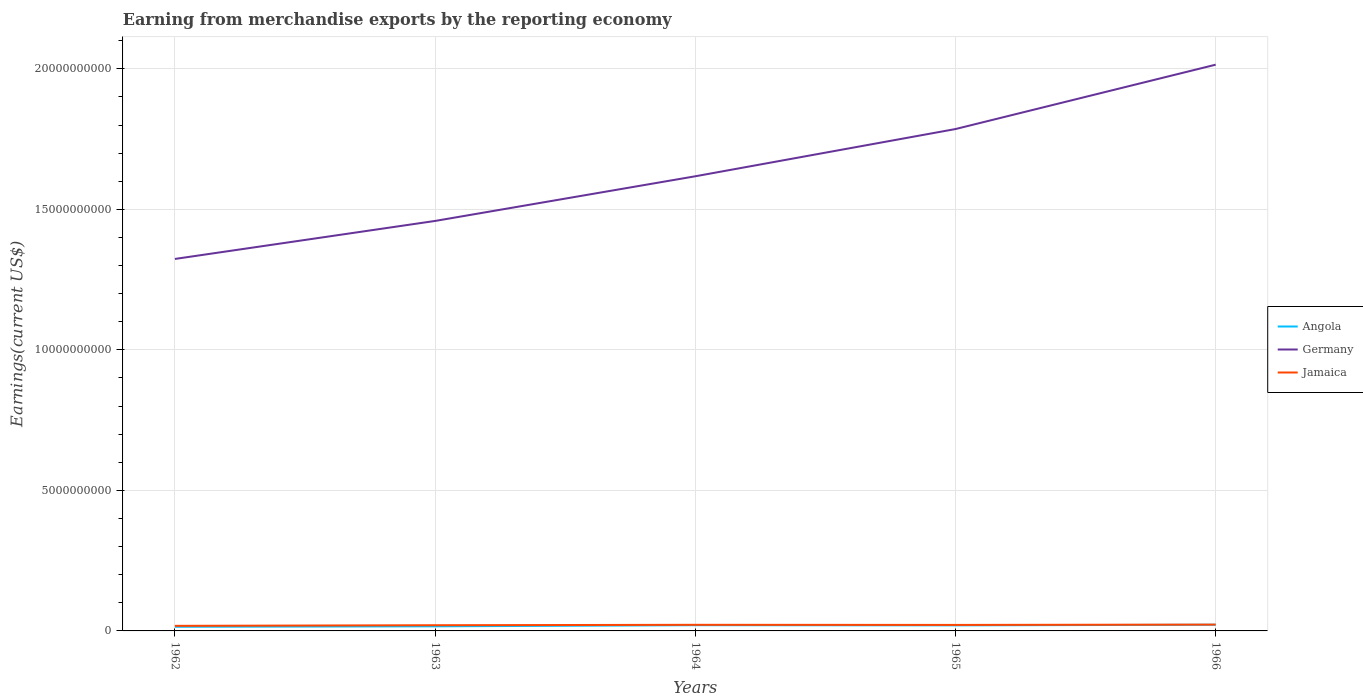How many different coloured lines are there?
Your answer should be compact. 3. Across all years, what is the maximum amount earned from merchandise exports in Jamaica?
Your response must be concise. 1.81e+08. In which year was the amount earned from merchandise exports in Angola maximum?
Offer a very short reply. 1962. What is the total amount earned from merchandise exports in Angola in the graph?
Your response must be concise. -1.62e+07. What is the difference between the highest and the second highest amount earned from merchandise exports in Germany?
Give a very brief answer. 6.91e+09. How many years are there in the graph?
Make the answer very short. 5. Does the graph contain any zero values?
Keep it short and to the point. No. Where does the legend appear in the graph?
Your response must be concise. Center right. How are the legend labels stacked?
Provide a short and direct response. Vertical. What is the title of the graph?
Make the answer very short. Earning from merchandise exports by the reporting economy. What is the label or title of the X-axis?
Your answer should be very brief. Years. What is the label or title of the Y-axis?
Your response must be concise. Earnings(current US$). What is the Earnings(current US$) in Angola in 1962?
Keep it short and to the point. 1.48e+08. What is the Earnings(current US$) in Germany in 1962?
Your response must be concise. 1.32e+1. What is the Earnings(current US$) in Jamaica in 1962?
Give a very brief answer. 1.81e+08. What is the Earnings(current US$) in Angola in 1963?
Make the answer very short. 1.64e+08. What is the Earnings(current US$) in Germany in 1963?
Provide a succinct answer. 1.46e+1. What is the Earnings(current US$) of Jamaica in 1963?
Give a very brief answer. 2.03e+08. What is the Earnings(current US$) of Angola in 1964?
Offer a very short reply. 2.04e+08. What is the Earnings(current US$) in Germany in 1964?
Keep it short and to the point. 1.62e+1. What is the Earnings(current US$) in Jamaica in 1964?
Offer a terse response. 2.18e+08. What is the Earnings(current US$) of Angola in 1965?
Your answer should be compact. 1.98e+08. What is the Earnings(current US$) of Germany in 1965?
Your response must be concise. 1.79e+1. What is the Earnings(current US$) of Jamaica in 1965?
Offer a terse response. 2.14e+08. What is the Earnings(current US$) of Angola in 1966?
Give a very brief answer. 2.20e+08. What is the Earnings(current US$) of Germany in 1966?
Keep it short and to the point. 2.01e+1. What is the Earnings(current US$) in Jamaica in 1966?
Ensure brevity in your answer.  2.25e+08. Across all years, what is the maximum Earnings(current US$) of Angola?
Your answer should be compact. 2.20e+08. Across all years, what is the maximum Earnings(current US$) of Germany?
Offer a terse response. 2.01e+1. Across all years, what is the maximum Earnings(current US$) of Jamaica?
Provide a succinct answer. 2.25e+08. Across all years, what is the minimum Earnings(current US$) in Angola?
Give a very brief answer. 1.48e+08. Across all years, what is the minimum Earnings(current US$) in Germany?
Ensure brevity in your answer.  1.32e+1. Across all years, what is the minimum Earnings(current US$) in Jamaica?
Offer a terse response. 1.81e+08. What is the total Earnings(current US$) in Angola in the graph?
Offer a terse response. 9.34e+08. What is the total Earnings(current US$) in Germany in the graph?
Provide a short and direct response. 8.20e+1. What is the total Earnings(current US$) in Jamaica in the graph?
Ensure brevity in your answer.  1.04e+09. What is the difference between the Earnings(current US$) in Angola in 1962 and that in 1963?
Make the answer very short. -1.58e+07. What is the difference between the Earnings(current US$) of Germany in 1962 and that in 1963?
Make the answer very short. -1.35e+09. What is the difference between the Earnings(current US$) in Jamaica in 1962 and that in 1963?
Provide a succinct answer. -2.21e+07. What is the difference between the Earnings(current US$) in Angola in 1962 and that in 1964?
Your answer should be very brief. -5.64e+07. What is the difference between the Earnings(current US$) in Germany in 1962 and that in 1964?
Provide a succinct answer. -2.94e+09. What is the difference between the Earnings(current US$) in Jamaica in 1962 and that in 1964?
Offer a very short reply. -3.68e+07. What is the difference between the Earnings(current US$) of Angola in 1962 and that in 1965?
Offer a terse response. -5.03e+07. What is the difference between the Earnings(current US$) in Germany in 1962 and that in 1965?
Keep it short and to the point. -4.62e+09. What is the difference between the Earnings(current US$) in Jamaica in 1962 and that in 1965?
Ensure brevity in your answer.  -3.29e+07. What is the difference between the Earnings(current US$) in Angola in 1962 and that in 1966?
Your response must be concise. -7.26e+07. What is the difference between the Earnings(current US$) in Germany in 1962 and that in 1966?
Ensure brevity in your answer.  -6.91e+09. What is the difference between the Earnings(current US$) in Jamaica in 1962 and that in 1966?
Offer a terse response. -4.45e+07. What is the difference between the Earnings(current US$) in Angola in 1963 and that in 1964?
Your answer should be very brief. -4.06e+07. What is the difference between the Earnings(current US$) in Germany in 1963 and that in 1964?
Offer a terse response. -1.59e+09. What is the difference between the Earnings(current US$) of Jamaica in 1963 and that in 1964?
Make the answer very short. -1.47e+07. What is the difference between the Earnings(current US$) of Angola in 1963 and that in 1965?
Ensure brevity in your answer.  -3.45e+07. What is the difference between the Earnings(current US$) of Germany in 1963 and that in 1965?
Provide a succinct answer. -3.27e+09. What is the difference between the Earnings(current US$) in Jamaica in 1963 and that in 1965?
Provide a short and direct response. -1.08e+07. What is the difference between the Earnings(current US$) in Angola in 1963 and that in 1966?
Offer a very short reply. -5.68e+07. What is the difference between the Earnings(current US$) of Germany in 1963 and that in 1966?
Provide a succinct answer. -5.56e+09. What is the difference between the Earnings(current US$) of Jamaica in 1963 and that in 1966?
Your response must be concise. -2.24e+07. What is the difference between the Earnings(current US$) in Angola in 1964 and that in 1965?
Your answer should be very brief. 6.10e+06. What is the difference between the Earnings(current US$) of Germany in 1964 and that in 1965?
Give a very brief answer. -1.68e+09. What is the difference between the Earnings(current US$) in Jamaica in 1964 and that in 1965?
Provide a succinct answer. 3.90e+06. What is the difference between the Earnings(current US$) of Angola in 1964 and that in 1966?
Provide a short and direct response. -1.62e+07. What is the difference between the Earnings(current US$) in Germany in 1964 and that in 1966?
Offer a very short reply. -3.97e+09. What is the difference between the Earnings(current US$) in Jamaica in 1964 and that in 1966?
Offer a very short reply. -7.70e+06. What is the difference between the Earnings(current US$) of Angola in 1965 and that in 1966?
Your response must be concise. -2.23e+07. What is the difference between the Earnings(current US$) in Germany in 1965 and that in 1966?
Give a very brief answer. -2.29e+09. What is the difference between the Earnings(current US$) in Jamaica in 1965 and that in 1966?
Your response must be concise. -1.16e+07. What is the difference between the Earnings(current US$) in Angola in 1962 and the Earnings(current US$) in Germany in 1963?
Your response must be concise. -1.44e+1. What is the difference between the Earnings(current US$) of Angola in 1962 and the Earnings(current US$) of Jamaica in 1963?
Provide a short and direct response. -5.51e+07. What is the difference between the Earnings(current US$) in Germany in 1962 and the Earnings(current US$) in Jamaica in 1963?
Provide a succinct answer. 1.30e+1. What is the difference between the Earnings(current US$) of Angola in 1962 and the Earnings(current US$) of Germany in 1964?
Offer a very short reply. -1.60e+1. What is the difference between the Earnings(current US$) of Angola in 1962 and the Earnings(current US$) of Jamaica in 1964?
Offer a very short reply. -6.98e+07. What is the difference between the Earnings(current US$) in Germany in 1962 and the Earnings(current US$) in Jamaica in 1964?
Offer a terse response. 1.30e+1. What is the difference between the Earnings(current US$) in Angola in 1962 and the Earnings(current US$) in Germany in 1965?
Your answer should be very brief. -1.77e+1. What is the difference between the Earnings(current US$) of Angola in 1962 and the Earnings(current US$) of Jamaica in 1965?
Your answer should be compact. -6.59e+07. What is the difference between the Earnings(current US$) of Germany in 1962 and the Earnings(current US$) of Jamaica in 1965?
Your answer should be compact. 1.30e+1. What is the difference between the Earnings(current US$) of Angola in 1962 and the Earnings(current US$) of Germany in 1966?
Offer a very short reply. -2.00e+1. What is the difference between the Earnings(current US$) in Angola in 1962 and the Earnings(current US$) in Jamaica in 1966?
Your response must be concise. -7.75e+07. What is the difference between the Earnings(current US$) in Germany in 1962 and the Earnings(current US$) in Jamaica in 1966?
Provide a short and direct response. 1.30e+1. What is the difference between the Earnings(current US$) of Angola in 1963 and the Earnings(current US$) of Germany in 1964?
Your response must be concise. -1.60e+1. What is the difference between the Earnings(current US$) of Angola in 1963 and the Earnings(current US$) of Jamaica in 1964?
Provide a short and direct response. -5.40e+07. What is the difference between the Earnings(current US$) of Germany in 1963 and the Earnings(current US$) of Jamaica in 1964?
Give a very brief answer. 1.44e+1. What is the difference between the Earnings(current US$) of Angola in 1963 and the Earnings(current US$) of Germany in 1965?
Your response must be concise. -1.77e+1. What is the difference between the Earnings(current US$) in Angola in 1963 and the Earnings(current US$) in Jamaica in 1965?
Make the answer very short. -5.01e+07. What is the difference between the Earnings(current US$) of Germany in 1963 and the Earnings(current US$) of Jamaica in 1965?
Provide a succinct answer. 1.44e+1. What is the difference between the Earnings(current US$) in Angola in 1963 and the Earnings(current US$) in Germany in 1966?
Keep it short and to the point. -2.00e+1. What is the difference between the Earnings(current US$) of Angola in 1963 and the Earnings(current US$) of Jamaica in 1966?
Make the answer very short. -6.17e+07. What is the difference between the Earnings(current US$) of Germany in 1963 and the Earnings(current US$) of Jamaica in 1966?
Keep it short and to the point. 1.44e+1. What is the difference between the Earnings(current US$) in Angola in 1964 and the Earnings(current US$) in Germany in 1965?
Your answer should be very brief. -1.77e+1. What is the difference between the Earnings(current US$) of Angola in 1964 and the Earnings(current US$) of Jamaica in 1965?
Your answer should be very brief. -9.50e+06. What is the difference between the Earnings(current US$) in Germany in 1964 and the Earnings(current US$) in Jamaica in 1965?
Keep it short and to the point. 1.60e+1. What is the difference between the Earnings(current US$) of Angola in 1964 and the Earnings(current US$) of Germany in 1966?
Make the answer very short. -1.99e+1. What is the difference between the Earnings(current US$) of Angola in 1964 and the Earnings(current US$) of Jamaica in 1966?
Your answer should be very brief. -2.11e+07. What is the difference between the Earnings(current US$) of Germany in 1964 and the Earnings(current US$) of Jamaica in 1966?
Ensure brevity in your answer.  1.60e+1. What is the difference between the Earnings(current US$) in Angola in 1965 and the Earnings(current US$) in Germany in 1966?
Ensure brevity in your answer.  -1.99e+1. What is the difference between the Earnings(current US$) in Angola in 1965 and the Earnings(current US$) in Jamaica in 1966?
Your answer should be very brief. -2.72e+07. What is the difference between the Earnings(current US$) in Germany in 1965 and the Earnings(current US$) in Jamaica in 1966?
Keep it short and to the point. 1.76e+1. What is the average Earnings(current US$) of Angola per year?
Ensure brevity in your answer.  1.87e+08. What is the average Earnings(current US$) of Germany per year?
Offer a terse response. 1.64e+1. What is the average Earnings(current US$) in Jamaica per year?
Provide a succinct answer. 2.08e+08. In the year 1962, what is the difference between the Earnings(current US$) in Angola and Earnings(current US$) in Germany?
Make the answer very short. -1.31e+1. In the year 1962, what is the difference between the Earnings(current US$) of Angola and Earnings(current US$) of Jamaica?
Make the answer very short. -3.30e+07. In the year 1962, what is the difference between the Earnings(current US$) in Germany and Earnings(current US$) in Jamaica?
Make the answer very short. 1.31e+1. In the year 1963, what is the difference between the Earnings(current US$) in Angola and Earnings(current US$) in Germany?
Your response must be concise. -1.44e+1. In the year 1963, what is the difference between the Earnings(current US$) of Angola and Earnings(current US$) of Jamaica?
Your answer should be compact. -3.93e+07. In the year 1963, what is the difference between the Earnings(current US$) of Germany and Earnings(current US$) of Jamaica?
Provide a short and direct response. 1.44e+1. In the year 1964, what is the difference between the Earnings(current US$) of Angola and Earnings(current US$) of Germany?
Keep it short and to the point. -1.60e+1. In the year 1964, what is the difference between the Earnings(current US$) of Angola and Earnings(current US$) of Jamaica?
Provide a short and direct response. -1.34e+07. In the year 1964, what is the difference between the Earnings(current US$) of Germany and Earnings(current US$) of Jamaica?
Ensure brevity in your answer.  1.60e+1. In the year 1965, what is the difference between the Earnings(current US$) of Angola and Earnings(current US$) of Germany?
Give a very brief answer. -1.77e+1. In the year 1965, what is the difference between the Earnings(current US$) in Angola and Earnings(current US$) in Jamaica?
Your answer should be compact. -1.56e+07. In the year 1965, what is the difference between the Earnings(current US$) of Germany and Earnings(current US$) of Jamaica?
Offer a terse response. 1.76e+1. In the year 1966, what is the difference between the Earnings(current US$) in Angola and Earnings(current US$) in Germany?
Make the answer very short. -1.99e+1. In the year 1966, what is the difference between the Earnings(current US$) of Angola and Earnings(current US$) of Jamaica?
Give a very brief answer. -4.90e+06. In the year 1966, what is the difference between the Earnings(current US$) in Germany and Earnings(current US$) in Jamaica?
Make the answer very short. 1.99e+1. What is the ratio of the Earnings(current US$) in Angola in 1962 to that in 1963?
Keep it short and to the point. 0.9. What is the ratio of the Earnings(current US$) in Germany in 1962 to that in 1963?
Ensure brevity in your answer.  0.91. What is the ratio of the Earnings(current US$) of Jamaica in 1962 to that in 1963?
Give a very brief answer. 0.89. What is the ratio of the Earnings(current US$) in Angola in 1962 to that in 1964?
Your response must be concise. 0.72. What is the ratio of the Earnings(current US$) in Germany in 1962 to that in 1964?
Your answer should be very brief. 0.82. What is the ratio of the Earnings(current US$) of Jamaica in 1962 to that in 1964?
Keep it short and to the point. 0.83. What is the ratio of the Earnings(current US$) of Angola in 1962 to that in 1965?
Give a very brief answer. 0.75. What is the ratio of the Earnings(current US$) of Germany in 1962 to that in 1965?
Offer a very short reply. 0.74. What is the ratio of the Earnings(current US$) in Jamaica in 1962 to that in 1965?
Your answer should be compact. 0.85. What is the ratio of the Earnings(current US$) in Angola in 1962 to that in 1966?
Your answer should be very brief. 0.67. What is the ratio of the Earnings(current US$) of Germany in 1962 to that in 1966?
Keep it short and to the point. 0.66. What is the ratio of the Earnings(current US$) of Jamaica in 1962 to that in 1966?
Your response must be concise. 0.8. What is the ratio of the Earnings(current US$) in Angola in 1963 to that in 1964?
Offer a terse response. 0.8. What is the ratio of the Earnings(current US$) of Germany in 1963 to that in 1964?
Give a very brief answer. 0.9. What is the ratio of the Earnings(current US$) in Jamaica in 1963 to that in 1964?
Offer a very short reply. 0.93. What is the ratio of the Earnings(current US$) of Angola in 1963 to that in 1965?
Ensure brevity in your answer.  0.83. What is the ratio of the Earnings(current US$) in Germany in 1963 to that in 1965?
Give a very brief answer. 0.82. What is the ratio of the Earnings(current US$) of Jamaica in 1963 to that in 1965?
Your answer should be very brief. 0.95. What is the ratio of the Earnings(current US$) in Angola in 1963 to that in 1966?
Offer a terse response. 0.74. What is the ratio of the Earnings(current US$) of Germany in 1963 to that in 1966?
Your response must be concise. 0.72. What is the ratio of the Earnings(current US$) in Jamaica in 1963 to that in 1966?
Provide a succinct answer. 0.9. What is the ratio of the Earnings(current US$) of Angola in 1964 to that in 1965?
Your response must be concise. 1.03. What is the ratio of the Earnings(current US$) in Germany in 1964 to that in 1965?
Make the answer very short. 0.91. What is the ratio of the Earnings(current US$) in Jamaica in 1964 to that in 1965?
Give a very brief answer. 1.02. What is the ratio of the Earnings(current US$) of Angola in 1964 to that in 1966?
Offer a very short reply. 0.93. What is the ratio of the Earnings(current US$) of Germany in 1964 to that in 1966?
Offer a terse response. 0.8. What is the ratio of the Earnings(current US$) in Jamaica in 1964 to that in 1966?
Your answer should be compact. 0.97. What is the ratio of the Earnings(current US$) in Angola in 1965 to that in 1966?
Give a very brief answer. 0.9. What is the ratio of the Earnings(current US$) of Germany in 1965 to that in 1966?
Provide a short and direct response. 0.89. What is the ratio of the Earnings(current US$) of Jamaica in 1965 to that in 1966?
Your response must be concise. 0.95. What is the difference between the highest and the second highest Earnings(current US$) of Angola?
Your answer should be very brief. 1.62e+07. What is the difference between the highest and the second highest Earnings(current US$) of Germany?
Your answer should be compact. 2.29e+09. What is the difference between the highest and the second highest Earnings(current US$) in Jamaica?
Offer a very short reply. 7.70e+06. What is the difference between the highest and the lowest Earnings(current US$) in Angola?
Provide a short and direct response. 7.26e+07. What is the difference between the highest and the lowest Earnings(current US$) in Germany?
Your response must be concise. 6.91e+09. What is the difference between the highest and the lowest Earnings(current US$) of Jamaica?
Ensure brevity in your answer.  4.45e+07. 